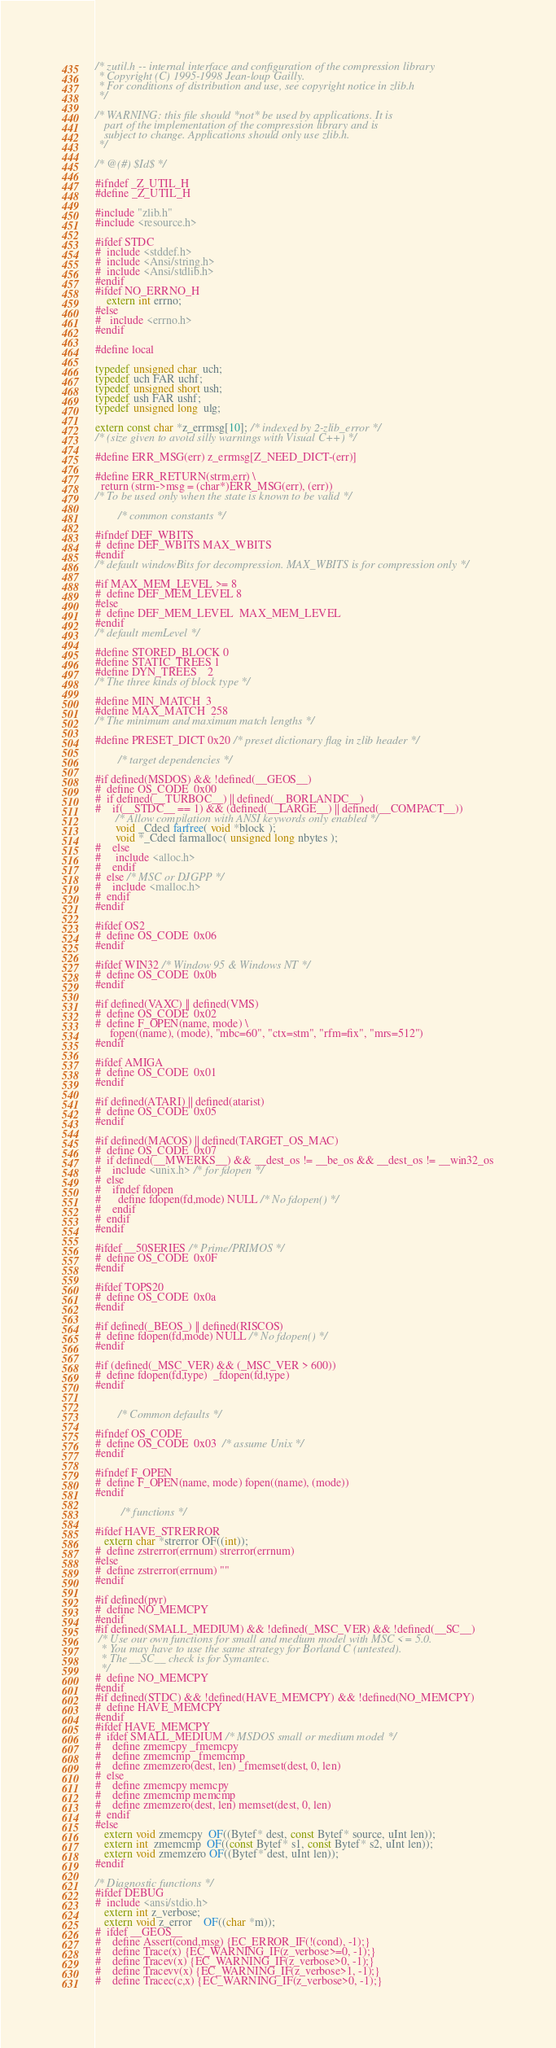Convert code to text. <code><loc_0><loc_0><loc_500><loc_500><_C_>/* zutil.h -- internal interface and configuration of the compression library
 * Copyright (C) 1995-1998 Jean-loup Gailly.
 * For conditions of distribution and use, see copyright notice in zlib.h
 */

/* WARNING: this file should *not* be used by applications. It is
   part of the implementation of the compression library and is
   subject to change. Applications should only use zlib.h.
 */

/* @(#) $Id$ */

#ifndef _Z_UTIL_H
#define _Z_UTIL_H

#include "zlib.h"
#include <resource.h>

#ifdef STDC
#  include <stddef.h>
#  include <Ansi/string.h>
#  include <Ansi/stdlib.h>
#endif
#ifdef NO_ERRNO_H
    extern int errno;
#else
#   include <errno.h>
#endif

#define local

typedef unsigned char  uch;
typedef uch FAR uchf;
typedef unsigned short ush;
typedef ush FAR ushf;
typedef unsigned long  ulg;

extern const char *z_errmsg[10]; /* indexed by 2-zlib_error */
/* (size given to avoid silly warnings with Visual C++) */

#define ERR_MSG(err) z_errmsg[Z_NEED_DICT-(err)]

#define ERR_RETURN(strm,err) \
  return (strm->msg = (char*)ERR_MSG(err), (err))
/* To be used only when the state is known to be valid */

        /* common constants */

#ifndef DEF_WBITS
#  define DEF_WBITS MAX_WBITS
#endif
/* default windowBits for decompression. MAX_WBITS is for compression only */

#if MAX_MEM_LEVEL >= 8
#  define DEF_MEM_LEVEL 8
#else
#  define DEF_MEM_LEVEL  MAX_MEM_LEVEL
#endif
/* default memLevel */

#define STORED_BLOCK 0
#define STATIC_TREES 1
#define DYN_TREES    2
/* The three kinds of block type */

#define MIN_MATCH  3
#define MAX_MATCH  258
/* The minimum and maximum match lengths */

#define PRESET_DICT 0x20 /* preset dictionary flag in zlib header */

        /* target dependencies */

#if defined(MSDOS) && !defined(__GEOS__)
#  define OS_CODE  0x00
#  if defined(__TURBOC__) || defined(__BORLANDC__)
#    if(__STDC__ == 1) && (defined(__LARGE__) || defined(__COMPACT__))
       /* Allow compilation with ANSI keywords only enabled */
       void _Cdecl farfree( void *block );
       void *_Cdecl farmalloc( unsigned long nbytes );
#    else
#     include <alloc.h>
#    endif
#  else /* MSC or DJGPP */
#    include <malloc.h>
#  endif
#endif

#ifdef OS2
#  define OS_CODE  0x06
#endif

#ifdef WIN32 /* Window 95 & Windows NT */
#  define OS_CODE  0x0b
#endif

#if defined(VAXC) || defined(VMS)
#  define OS_CODE  0x02
#  define F_OPEN(name, mode) \
     fopen((name), (mode), "mbc=60", "ctx=stm", "rfm=fix", "mrs=512")
#endif

#ifdef AMIGA
#  define OS_CODE  0x01
#endif

#if defined(ATARI) || defined(atarist)
#  define OS_CODE  0x05
#endif

#if defined(MACOS) || defined(TARGET_OS_MAC)
#  define OS_CODE  0x07
#  if defined(__MWERKS__) && __dest_os != __be_os && __dest_os != __win32_os
#    include <unix.h> /* for fdopen */
#  else
#    ifndef fdopen
#      define fdopen(fd,mode) NULL /* No fdopen() */
#    endif
#  endif
#endif

#ifdef __50SERIES /* Prime/PRIMOS */
#  define OS_CODE  0x0F
#endif

#ifdef TOPS20
#  define OS_CODE  0x0a
#endif

#if defined(_BEOS_) || defined(RISCOS)
#  define fdopen(fd,mode) NULL /* No fdopen() */
#endif

#if (defined(_MSC_VER) && (_MSC_VER > 600))
#  define fdopen(fd,type)  _fdopen(fd,type)
#endif


        /* Common defaults */

#ifndef OS_CODE
#  define OS_CODE  0x03  /* assume Unix */
#endif

#ifndef F_OPEN
#  define F_OPEN(name, mode) fopen((name), (mode))
#endif

         /* functions */

#ifdef HAVE_STRERROR
   extern char *strerror OF((int));
#  define zstrerror(errnum) strerror(errnum)
#else
#  define zstrerror(errnum) ""
#endif

#if defined(pyr)
#  define NO_MEMCPY
#endif
#if defined(SMALL_MEDIUM) && !defined(_MSC_VER) && !defined(__SC__)
 /* Use our own functions for small and medium model with MSC <= 5.0.
  * You may have to use the same strategy for Borland C (untested).
  * The __SC__ check is for Symantec.
  */
#  define NO_MEMCPY
#endif
#if defined(STDC) && !defined(HAVE_MEMCPY) && !defined(NO_MEMCPY)
#  define HAVE_MEMCPY
#endif
#ifdef HAVE_MEMCPY
#  ifdef SMALL_MEDIUM /* MSDOS small or medium model */
#    define zmemcpy _fmemcpy
#    define zmemcmp _fmemcmp
#    define zmemzero(dest, len) _fmemset(dest, 0, len)
#  else
#    define zmemcpy memcpy
#    define zmemcmp memcmp
#    define zmemzero(dest, len) memset(dest, 0, len)
#  endif
#else
   extern void zmemcpy  OF((Bytef* dest, const Bytef* source, uInt len));
   extern int  zmemcmp  OF((const Bytef* s1, const Bytef* s2, uInt len));
   extern void zmemzero OF((Bytef* dest, uInt len));
#endif

/* Diagnostic functions */
#ifdef DEBUG
#  include <ansi/stdio.h>
   extern int z_verbose;
   extern void z_error    OF((char *m));
#  ifdef __GEOS__
#    define Assert(cond,msg) {EC_ERROR_IF(!(cond), -1);}
#    define Trace(x) {EC_WARNING_IF(z_verbose>=0, -1);}
#    define Tracev(x) {EC_WARNING_IF(z_verbose>0, -1);}
#    define Tracevv(x) {EC_WARNING_IF(z_verbose>1, -1);}
#    define Tracec(c,x) {EC_WARNING_IF(z_verbose>0, -1);}</code> 